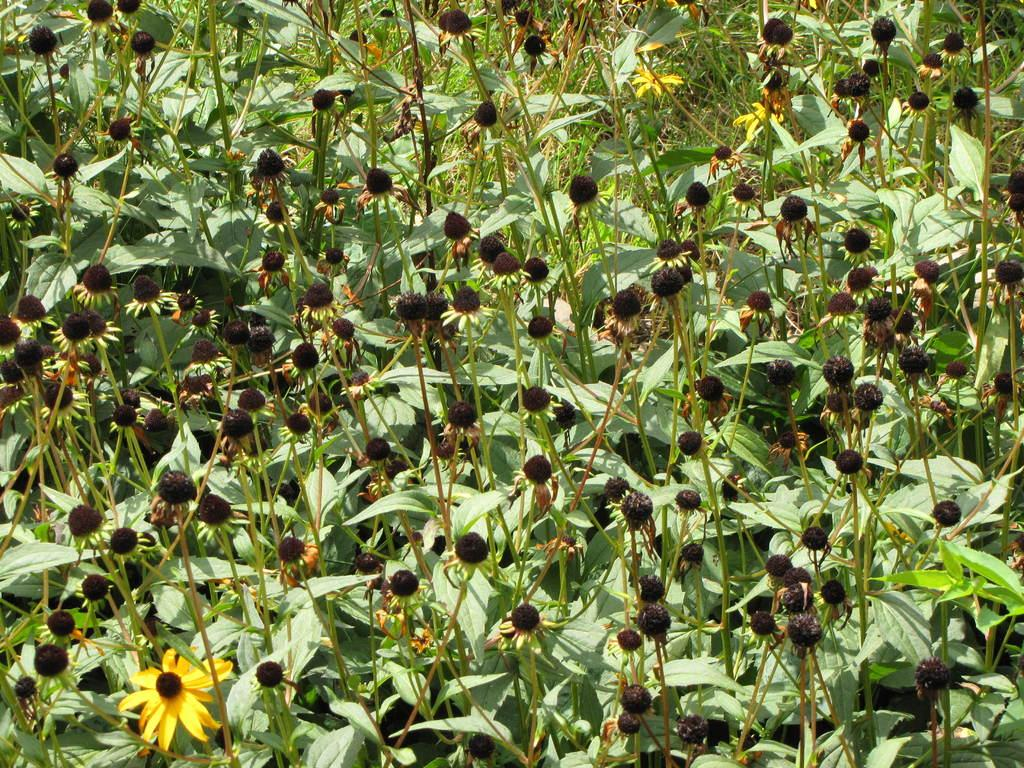What type of living organisms can be seen in the image? Plants can be seen in the image. What color are the leaves of the plants in the image? The plants have green leaves. What additional features can be observed on some of the plants? Some plants have seeds, and some have yellow flowers. What type of vegetation is visible in the background of the image? There is grass in the background of the image. What type of bulb is used to light up the plants in the image? There is no bulb present in the image; the plants are not illuminated by artificial light. 